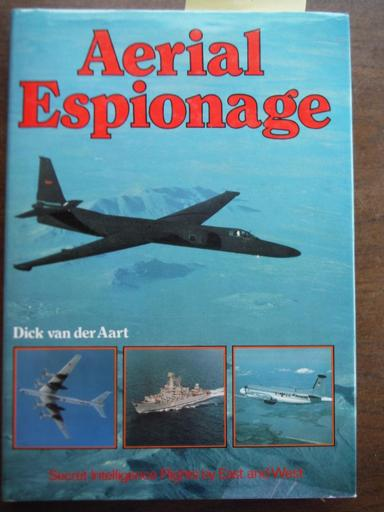What types of aircraft are depicted on the book cover, and what roles might they play in intelligence gathering? The book cover showcases a variety of military aircraft, including a large, sleek jet that is likely used for high-altitude reconnaissance missions. Additionally, there's a smaller, propeller-driven aircraft that could be used for signal interception or closer ground observation. These aircraft are key tools in strategic surveillance and data collection, pivotal for national security. 